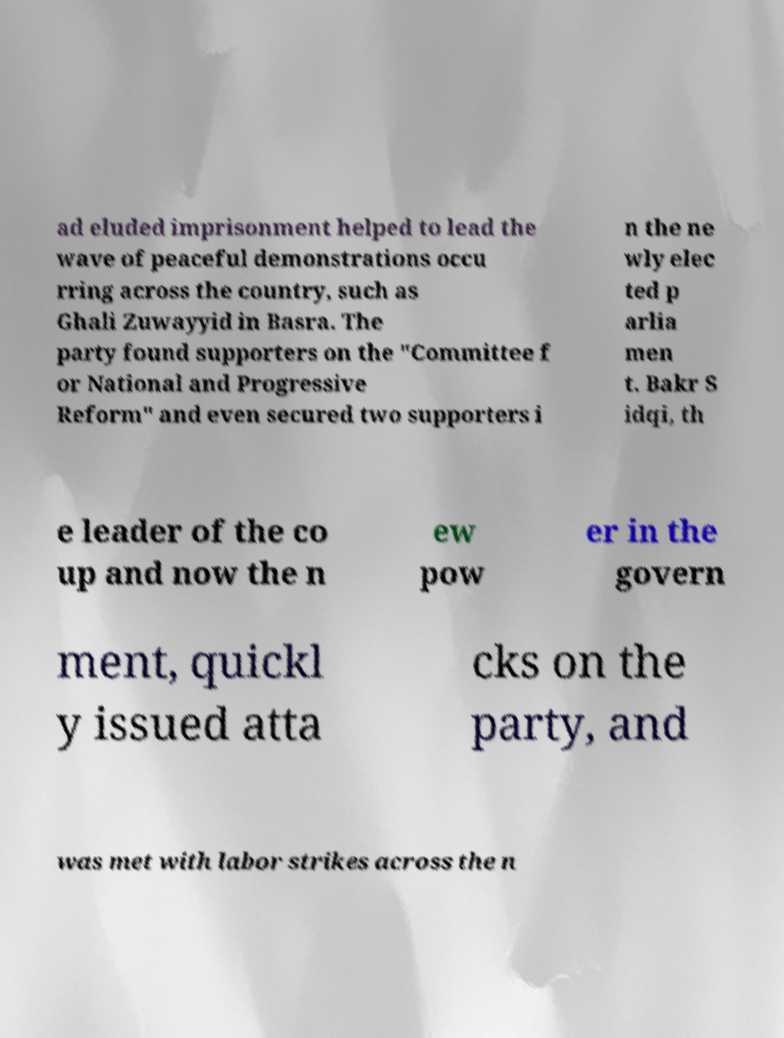For documentation purposes, I need the text within this image transcribed. Could you provide that? ad eluded imprisonment helped to lead the wave of peaceful demonstrations occu rring across the country, such as Ghali Zuwayyid in Basra. The party found supporters on the "Committee f or National and Progressive Reform" and even secured two supporters i n the ne wly elec ted p arlia men t. Bakr S idqi, th e leader of the co up and now the n ew pow er in the govern ment, quickl y issued atta cks on the party, and was met with labor strikes across the n 